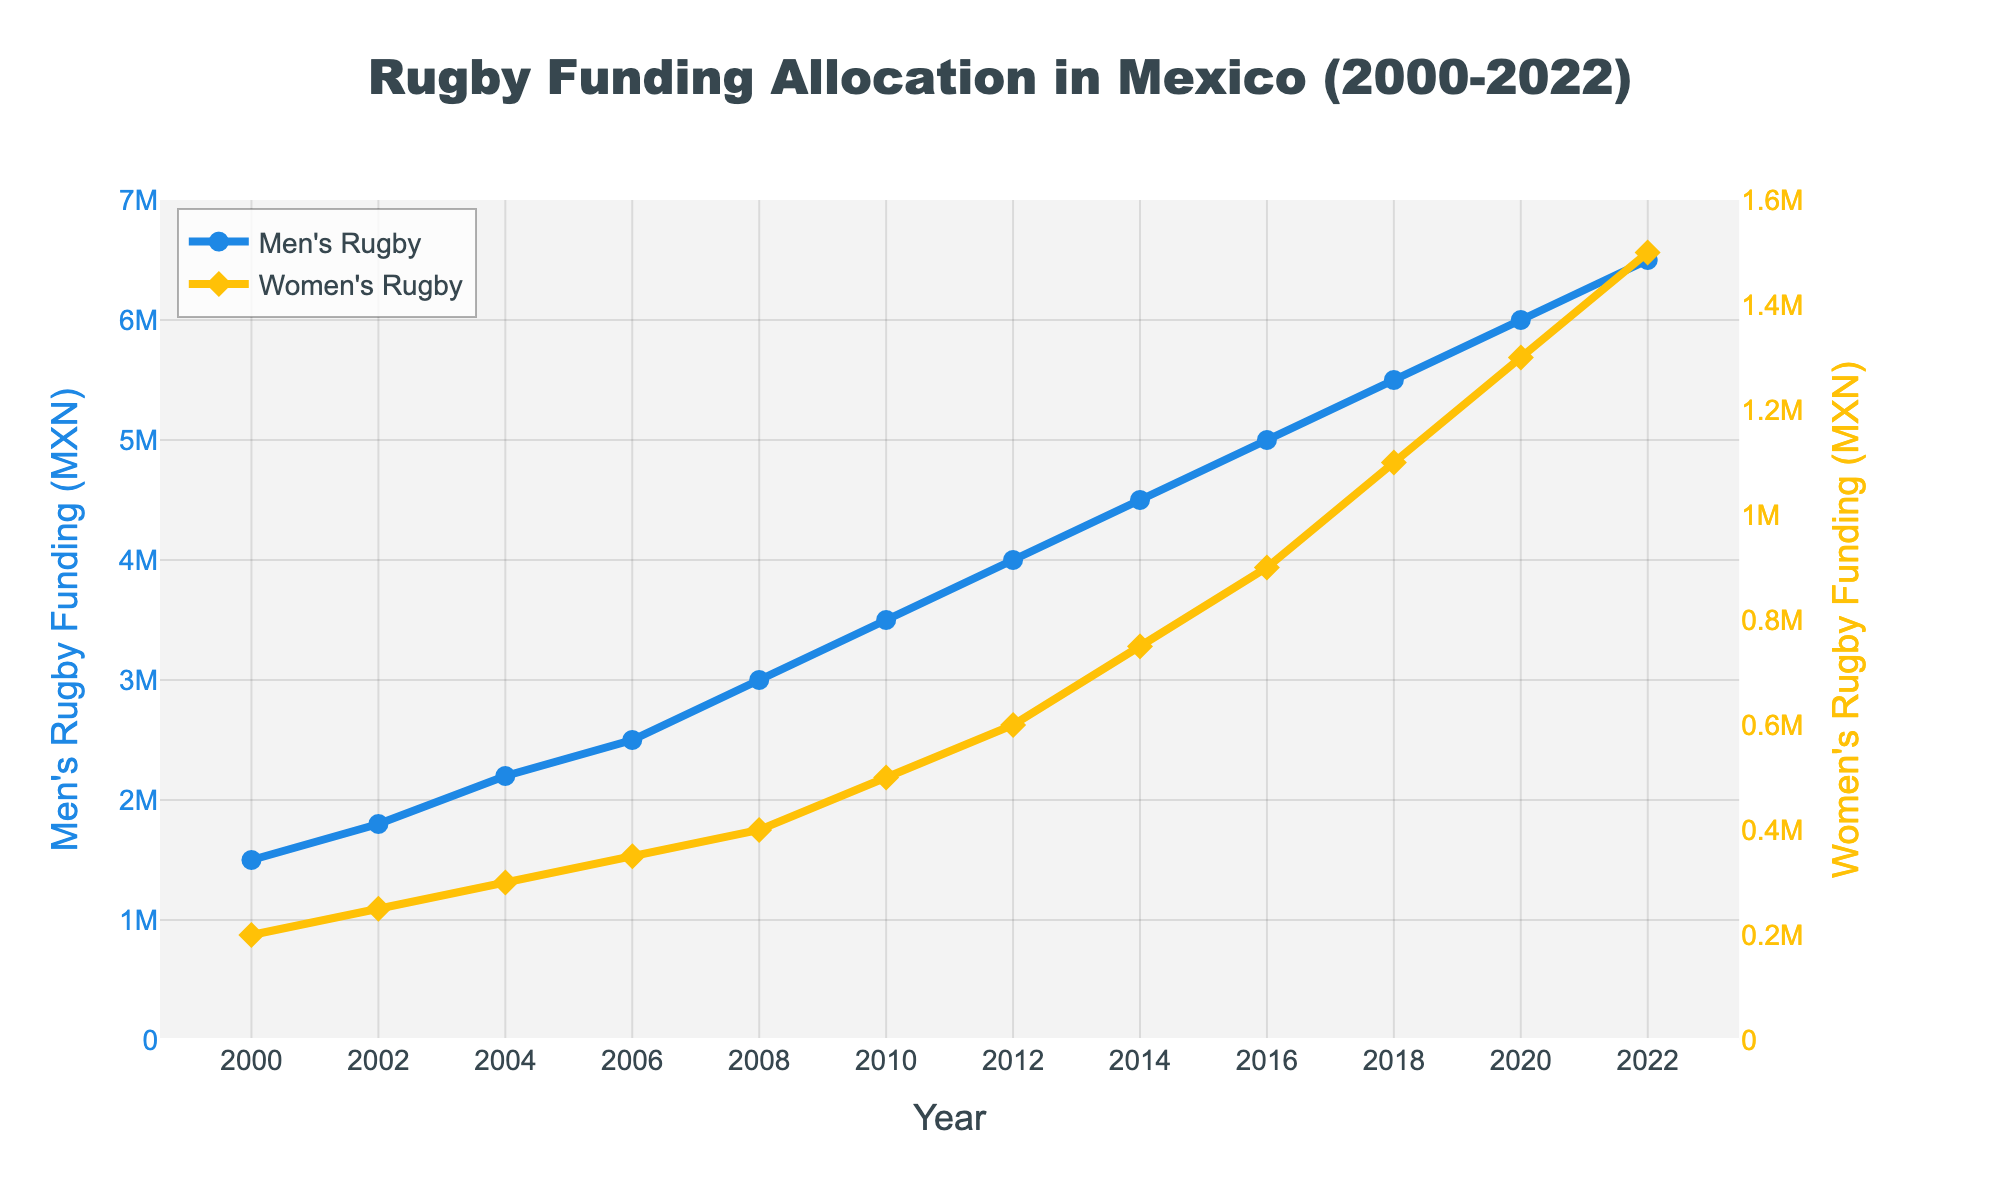What was the funding difference between men's and women's rugby in 2000? In 2000, the funding for men's rugby was 1,500,000 MXN and for women's rugby was 200,000 MXN. The difference is 1,500,000 - 200,000.
Answer: 1,300,000 MXN Which year shows the highest funding for women's rugby? By looking at the graph, the highest point on the yellow line (representing women's rugby) is in 2022, indicating the highest funding for women's rugby.
Answer: 2022 In which year did women's rugby funding first reach 1,000,000 MXN? The yellow line crosses the 1,000,000 MXN mark between 2016 and 2018. Observing the exact data points, we see 1,100,000 MXN in 2018.
Answer: 2018 How much more funding did men's rugby receive than women's rugby in 2010? In 2010, men's rugby funding was 3,500,000 MXN, and women's rugby funding was 500,000 MXN. The difference is 3,500,000 - 500,000.
Answer: 3,000,000 MXN What is the average funding for women's rugby over the entire period? Sum up the women's rugby funding values from 2000 to 2022: 200,000 + 250,000 + 300,000 + 350,000 + 400,000 + 500,000 + 600,000 + 750,000 + 900,000 + 1,100,000 + 1,300,000 + 1,500,000, which equals 8,150,000. Divide by 12 (number of years).
Answer: 679,167 MXN In which year did men's rugby funding exceed 4,000,000 MXN for the first time? Looking at the blue line, it crosses the 4,000,000 MXN mark between 2010 and 2012. Examining the exact data points, we see 4,000,000 MXN in 2012.
Answer: 2012 Comparing the trend lines, how has the relationship between men's and women's rugby funding changed over time? Initially, the gap between men's and women's rugby funding was large. However, over time, women's rugby funding has increased more significantly, reducing the gap slightly but still lagging behind men's rugby funding noticeably.
Answer: The gap has slightly reduced but still remains significant What was the percent increase in women's rugby funding from 2000 to 2022? Calculate the percent increase using the formula: ((Final amount - Initial amount) / Initial amount) * 100. For 2000 to 2022, ((1,500,000 - 200,000) / 200,000) * 100.
Answer: 650% By how much did men's rugby funding increase from 2008 to 2018? Increase = 2018 funding - 2008 funding. For men's rugby, 5,500,000 MXN - 3,000,000 MXN.
Answer: 2,500,000 MXN 